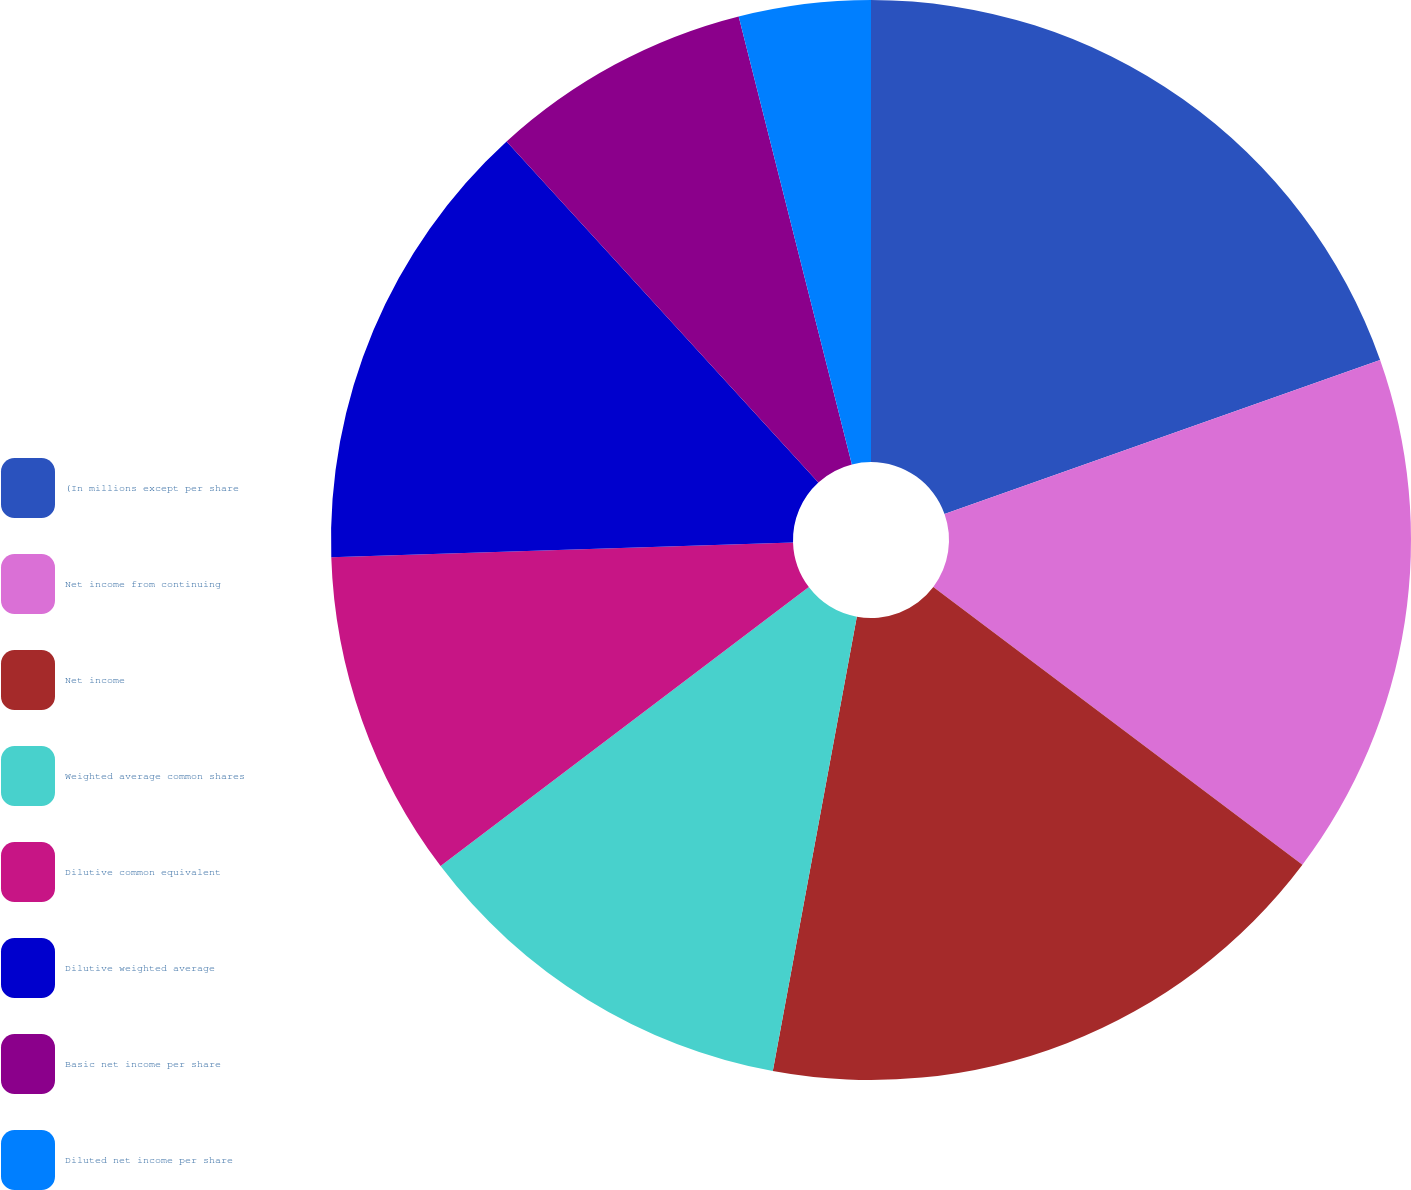<chart> <loc_0><loc_0><loc_500><loc_500><pie_chart><fcel>(In millions except per share<fcel>Net income from continuing<fcel>Net income<fcel>Weighted average common shares<fcel>Dilutive common equivalent<fcel>Dilutive weighted average<fcel>Basic net income per share<fcel>Diluted net income per share<nl><fcel>19.59%<fcel>15.68%<fcel>17.64%<fcel>11.77%<fcel>9.81%<fcel>13.72%<fcel>7.85%<fcel>3.94%<nl></chart> 